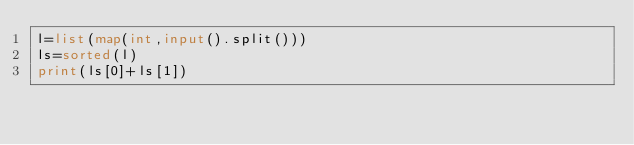Convert code to text. <code><loc_0><loc_0><loc_500><loc_500><_Python_>l=list(map(int,input().split()))
ls=sorted(l)
print(ls[0]+ls[1])</code> 